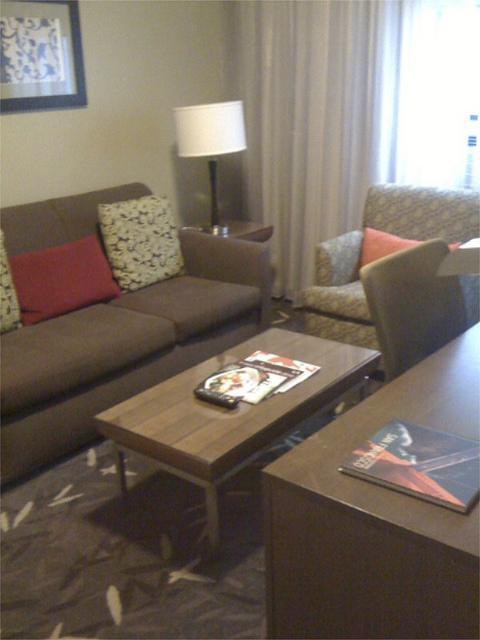How many chairs are there?
Give a very brief answer. 2. 